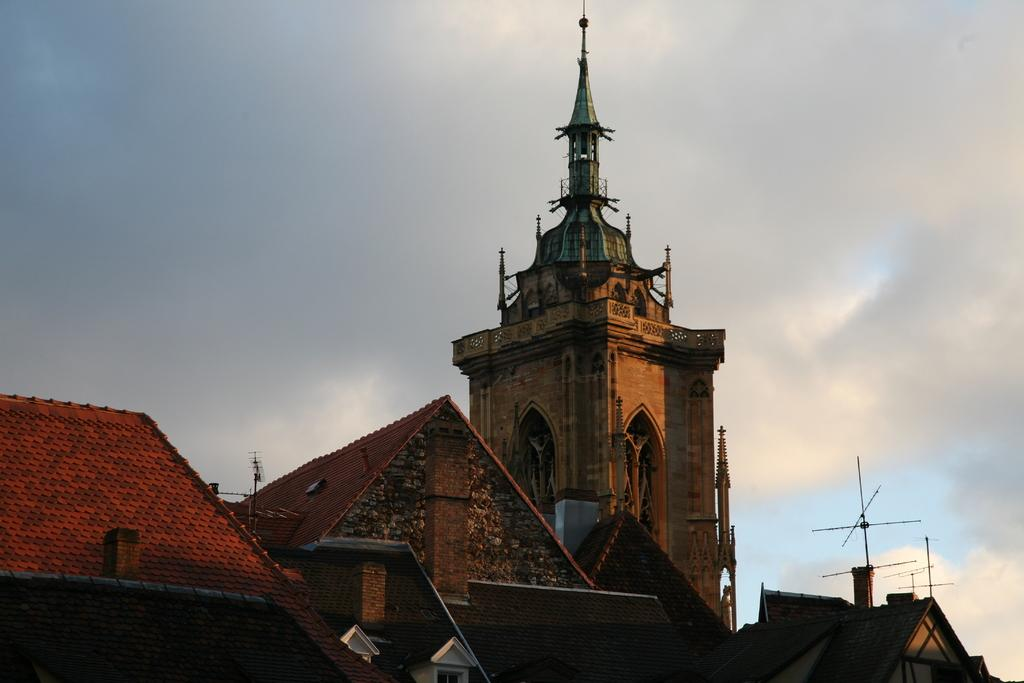What feature can be seen on the houses in the image? There are roots on the houses in the image. What construction activity is taking place in the image? There is a tower under construction in the image. What type of equipment is visible on the houses or buildings in the image? Television antennas are visible in the image. What can be seen in the sky in the image? Clouds are present in the sky in the image. What type of jeans is the tower wearing in the image? There are no jeans present in the image, as the tower is a structure and not a person. How many bits of information can be found in the image? The concept of "bits" is not applicable to the image, as it refers to digital data and not visual elements. 